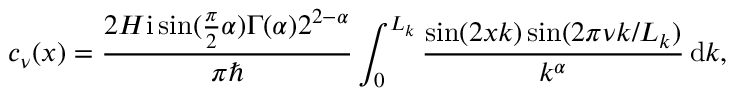Convert formula to latex. <formula><loc_0><loc_0><loc_500><loc_500>c _ { \nu } ( x ) = \frac { 2 H i \sin ( \frac { \pi } { 2 } \alpha ) \Gamma ( \alpha ) 2 ^ { 2 - \alpha } } { \pi } \int _ { 0 } ^ { L _ { k } } \frac { \sin ( 2 x k ) \sin ( 2 \pi \nu k / L _ { k } ) } { k ^ { \alpha } } \, d k ,</formula> 